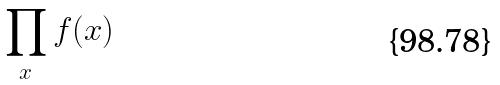Convert formula to latex. <formula><loc_0><loc_0><loc_500><loc_500>\prod _ { x } f ( x )</formula> 